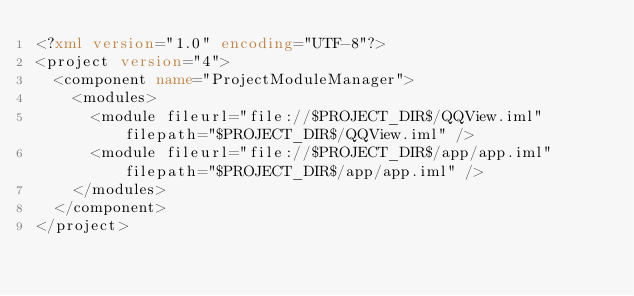Convert code to text. <code><loc_0><loc_0><loc_500><loc_500><_XML_><?xml version="1.0" encoding="UTF-8"?>
<project version="4">
  <component name="ProjectModuleManager">
    <modules>
      <module fileurl="file://$PROJECT_DIR$/QQView.iml" filepath="$PROJECT_DIR$/QQView.iml" />
      <module fileurl="file://$PROJECT_DIR$/app/app.iml" filepath="$PROJECT_DIR$/app/app.iml" />
    </modules>
  </component>
</project></code> 